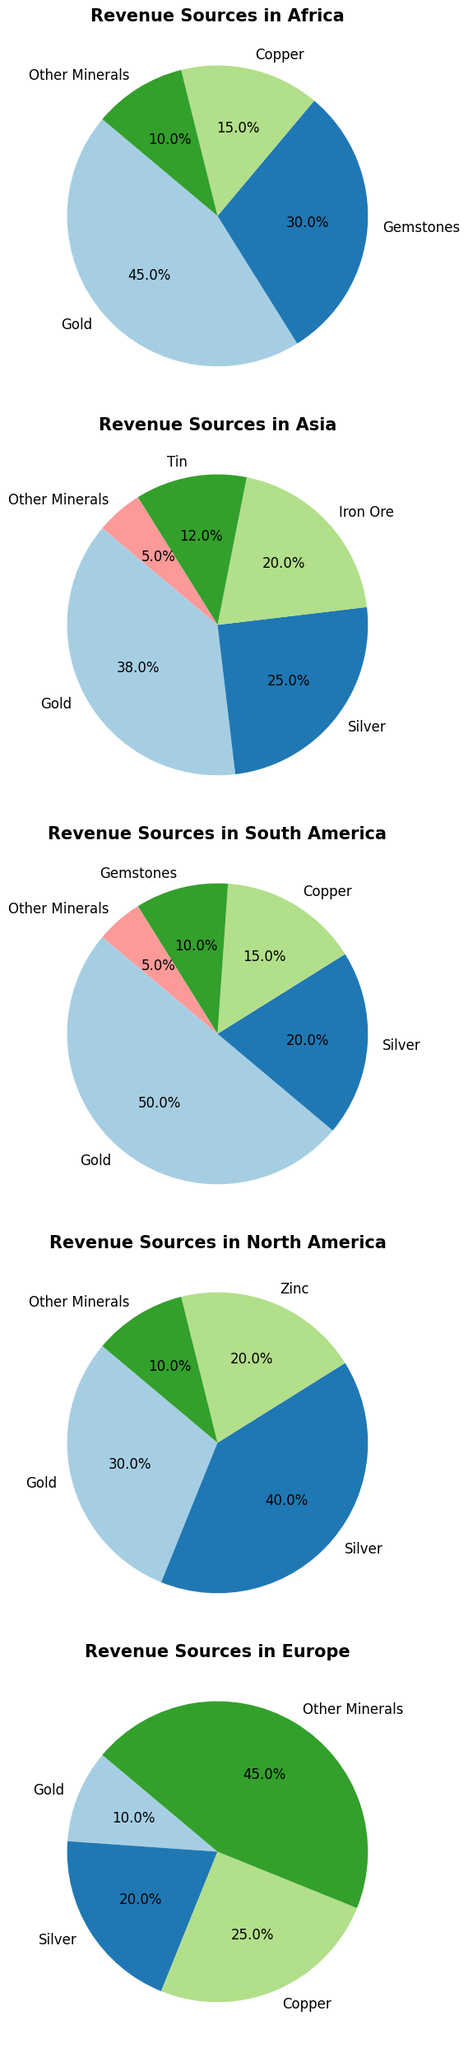What is the largest revenue source for small-scale miners in Africa? Look at the pie chart for Africa. The segment labeled "Gold" has the largest percentage.
Answer: Gold Which region derives a greater percentage of revenue from Gemstones, Africa or South America? Compare the segments labeled "Gemstones" in both the Africa and South America pie charts. Africa has 30%, while South America has 10%.
Answer: Africa What is the total percentage of revenue from Gold across all regions? Sum the Gold percentages from each region: Africa (45%), Asia (38%), South America (50%), North America (30%), Europe (10%). The total is 45 + 38 + 50 + 30 + 10 = 173%.
Answer: 173% How does the revenue from Silver in Asia compare to that in North America? Compare the segments labeled "Silver" in the Asia and North America pie charts. Asia has 25%, while North America has 40%.
Answer: North America has more Which revenue source holds the highest percentage in Europe? Look at the largest segment in the Europe pie chart. The largest segment is labeled "Other Minerals" with 45%.
Answer: Other Minerals What percentage of revenue in South America comes from sources other than Gold? Subtract the percentage for Gold from 100% in the South America pie chart. The calculation is 100% - 50% = 50%.
Answer: 50% Which region has the highest dependence on a single revenue source, and what is that source? Identify the largest segments in each region's pie chart. South America's Gold has the largest single percentage at 50%.
Answer: South America, Gold What is the difference in percentage between Copper revenue in Africa and Silver revenue in Europe? Subtract the Copper percentage in Africa (15%) from the Silver percentage in Europe (20%). The calculation is 20% - 15% = 5%.
Answer: 5% In which region do "Other Minerals" contribute the least to the revenue? Find the smallest percentage labeled "Other Minerals" across all regions. Asia has the smallest percentage at 5%.
Answer: Asia 